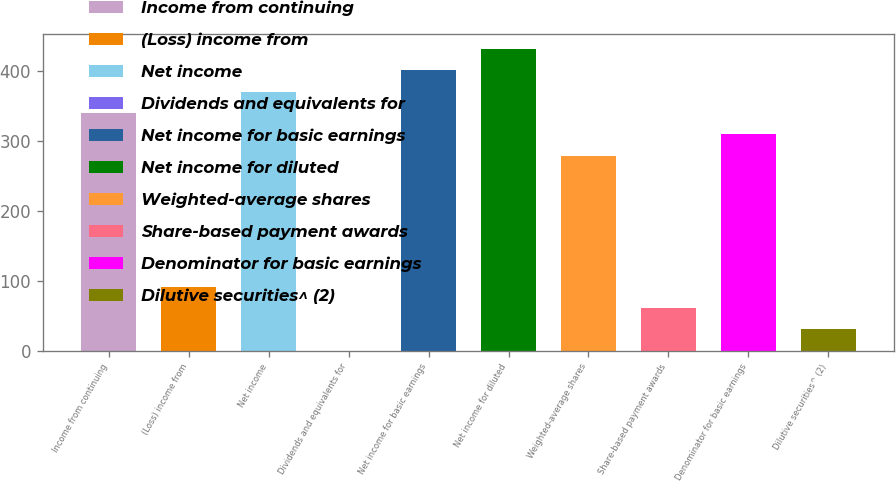Convert chart. <chart><loc_0><loc_0><loc_500><loc_500><bar_chart><fcel>Income from continuing<fcel>(Loss) income from<fcel>Net income<fcel>Dividends and equivalents for<fcel>Net income for basic earnings<fcel>Net income for diluted<fcel>Weighted-average shares<fcel>Share-based payment awards<fcel>Denominator for basic earnings<fcel>Dilutive securities^ (2)<nl><fcel>340.36<fcel>91.69<fcel>370.89<fcel>0.1<fcel>401.42<fcel>431.95<fcel>279.3<fcel>61.16<fcel>309.83<fcel>30.63<nl></chart> 